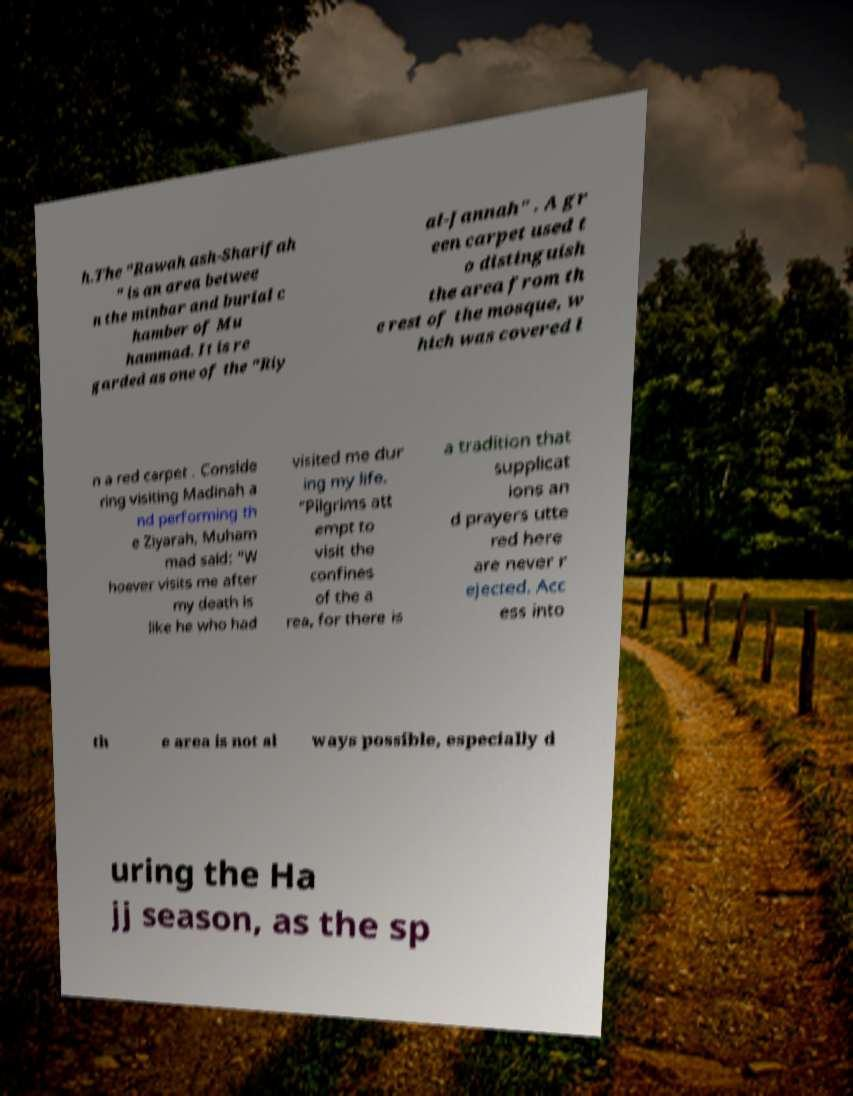Can you read and provide the text displayed in the image?This photo seems to have some interesting text. Can you extract and type it out for me? h.The "Rawah ash-Sharifah " is an area betwee n the minbar and burial c hamber of Mu hammad. It is re garded as one of the "Riy al-Jannah" . A gr een carpet used t o distinguish the area from th e rest of the mosque, w hich was covered i n a red carpet . Conside ring visiting Madinah a nd performing th e Ziyarah, Muham mad said: “W hoever visits me after my death is like he who had visited me dur ing my life. ”Pilgrims att empt to visit the confines of the a rea, for there is a tradition that supplicat ions an d prayers utte red here are never r ejected. Acc ess into th e area is not al ways possible, especially d uring the Ha jj season, as the sp 